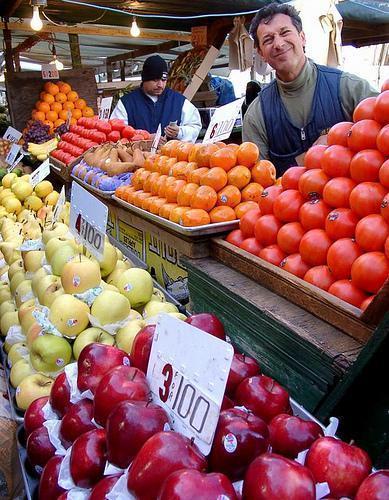What is the name of the red apples?
Make your selection from the four choices given to correctly answer the question.
Options: Ladybug, red delicious, dark red, savory. Red delicious. 